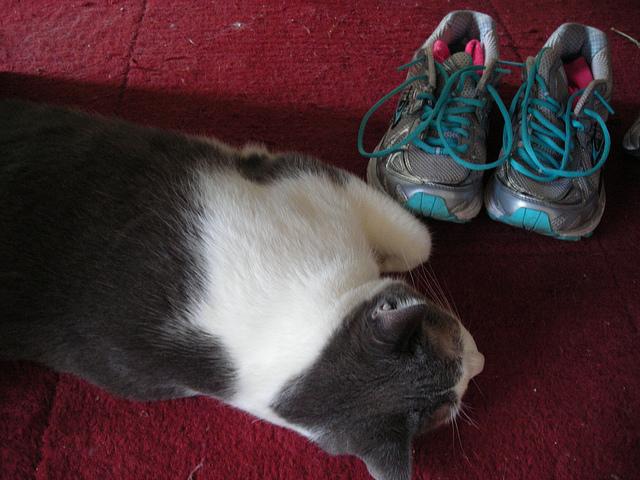How many shoes are visible in the photo?
Quick response, please. 2. Is this cat eating?
Write a very short answer. No. Is the cat sleeping?
Short answer required. Yes. What color is the cat?
Concise answer only. Gray and white. What is this cat laying on top of?
Short answer required. Carpet. What color are the sneakers?
Be succinct. Gray. What kind of animal is this?
Quick response, please. Cat. What type of cat is this?
Write a very short answer. Domestic. Is the cat wearing a collar?
Keep it brief. No. Are the cat's eyes open?
Concise answer only. No. What color is the carpet?
Write a very short answer. Red. Is the cat asleep?
Keep it brief. Yes. What color are the laces?
Short answer required. Blue. Is this cat wearing a collar?
Write a very short answer. No. Is the cat smelling?
Answer briefly. No. Is the cats hair standing up?
Keep it brief. No. What color is the shoe?
Write a very short answer. Gray. Is the cat playing with the shoes?
Quick response, please. No. Where is the cat sleeping?
Write a very short answer. Floor. Is this floor carpeted?
Give a very brief answer. Yes. Is this an object of art?
Concise answer only. No. Does the cat think this slipper is an animal?
Short answer required. No. Is the cat lying on a carpet?
Quick response, please. Yes. What is the cat doing?
Concise answer only. Sleeping. Do the shoes belong to the cat?
Write a very short answer. No. Where is the cat sitting?
Keep it brief. Floor. 